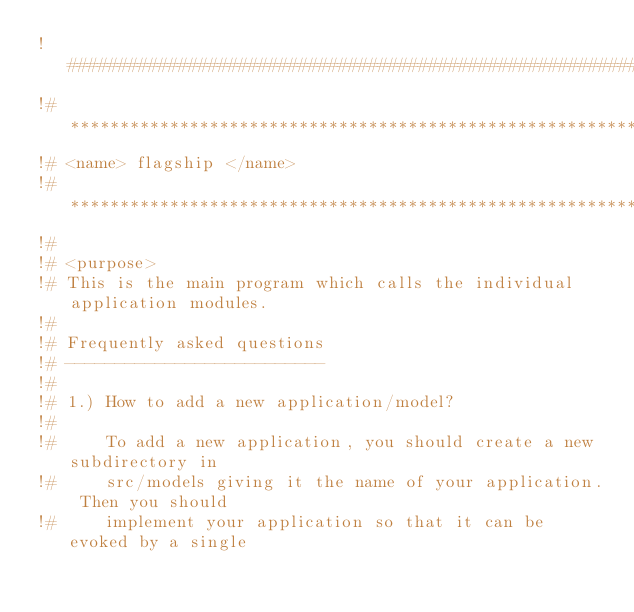<code> <loc_0><loc_0><loc_500><loc_500><_FORTRAN_>!##############################################################################
!# ****************************************************************************
!# <name> flagship </name>
!# ****************************************************************************
!#
!# <purpose>
!# This is the main program which calls the individual application modules.
!#
!# Frequently asked questions
!# --------------------------
!#
!# 1.) How to add a new application/model?
!#
!#     To add a new application, you should create a new subdirectory in
!#     src/models giving it the name of your application. Then you should
!#     implement your application so that it can be evoked by a single</code> 